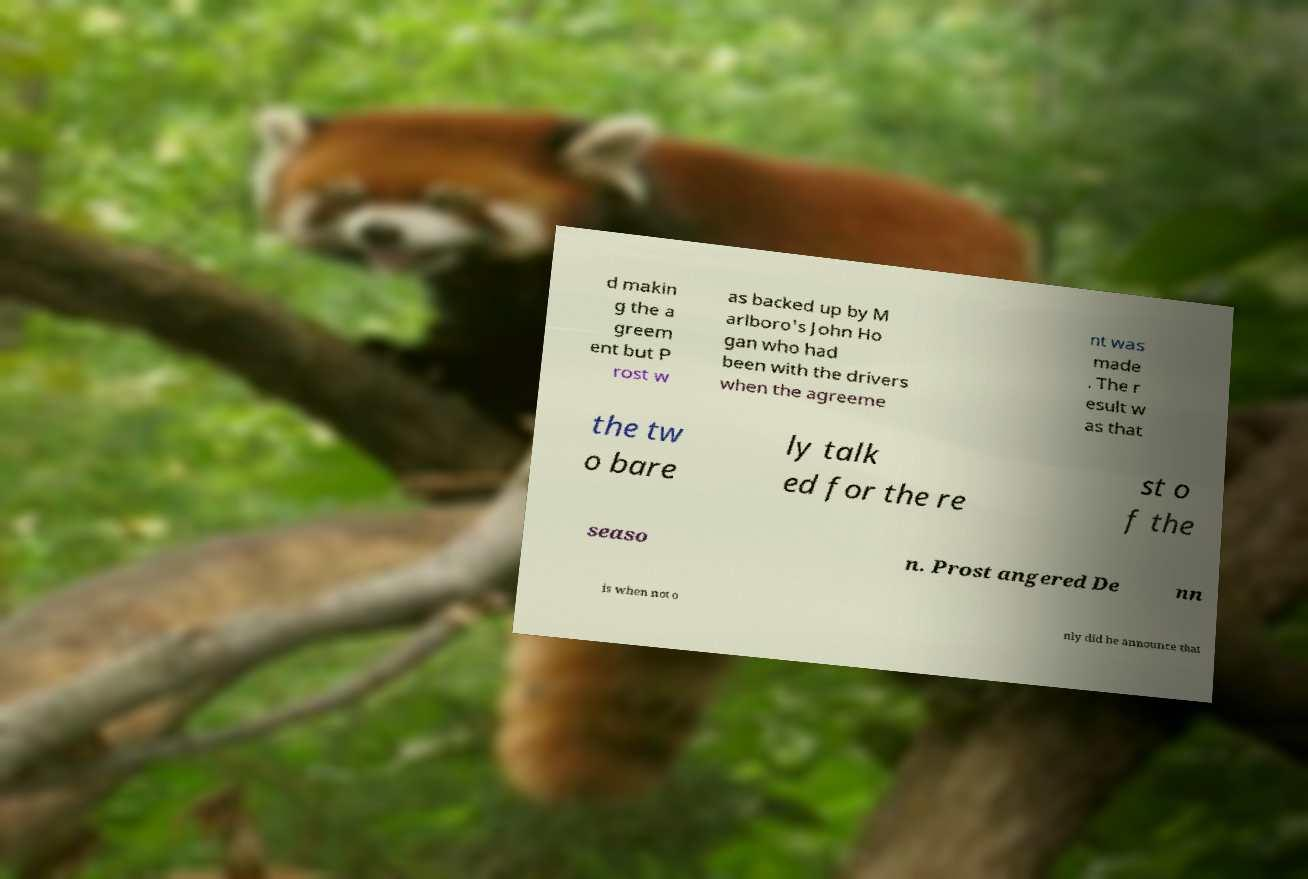I need the written content from this picture converted into text. Can you do that? d makin g the a greem ent but P rost w as backed up by M arlboro's John Ho gan who had been with the drivers when the agreeme nt was made . The r esult w as that the tw o bare ly talk ed for the re st o f the seaso n. Prost angered De nn is when not o nly did he announce that 